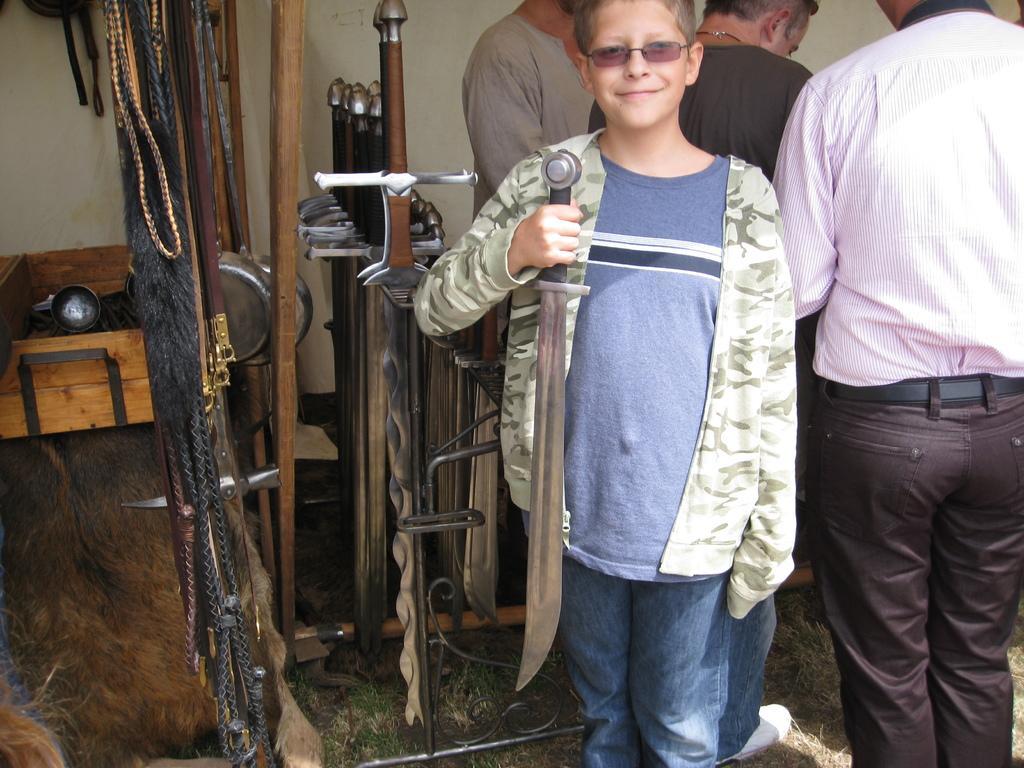In one or two sentences, can you explain what this image depicts? In this image I can see a person wearing blue and green colored dress is standing and holding a knife in his hand. I can see few other knives, few ropes and few persons standing. In the background I can see the wall and few other objects. 